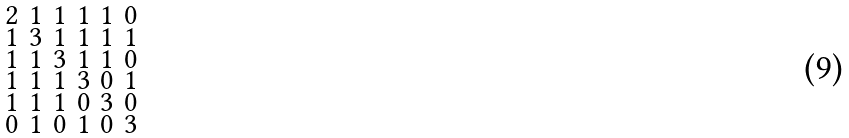Convert formula to latex. <formula><loc_0><loc_0><loc_500><loc_500>\begin{smallmatrix} 2 & 1 & 1 & 1 & 1 & 0 \\ 1 & 3 & 1 & 1 & 1 & 1 \\ 1 & 1 & 3 & 1 & 1 & 0 \\ 1 & 1 & 1 & 3 & 0 & 1 \\ 1 & 1 & 1 & 0 & 3 & 0 \\ 0 & 1 & 0 & 1 & 0 & 3 \end{smallmatrix}</formula> 